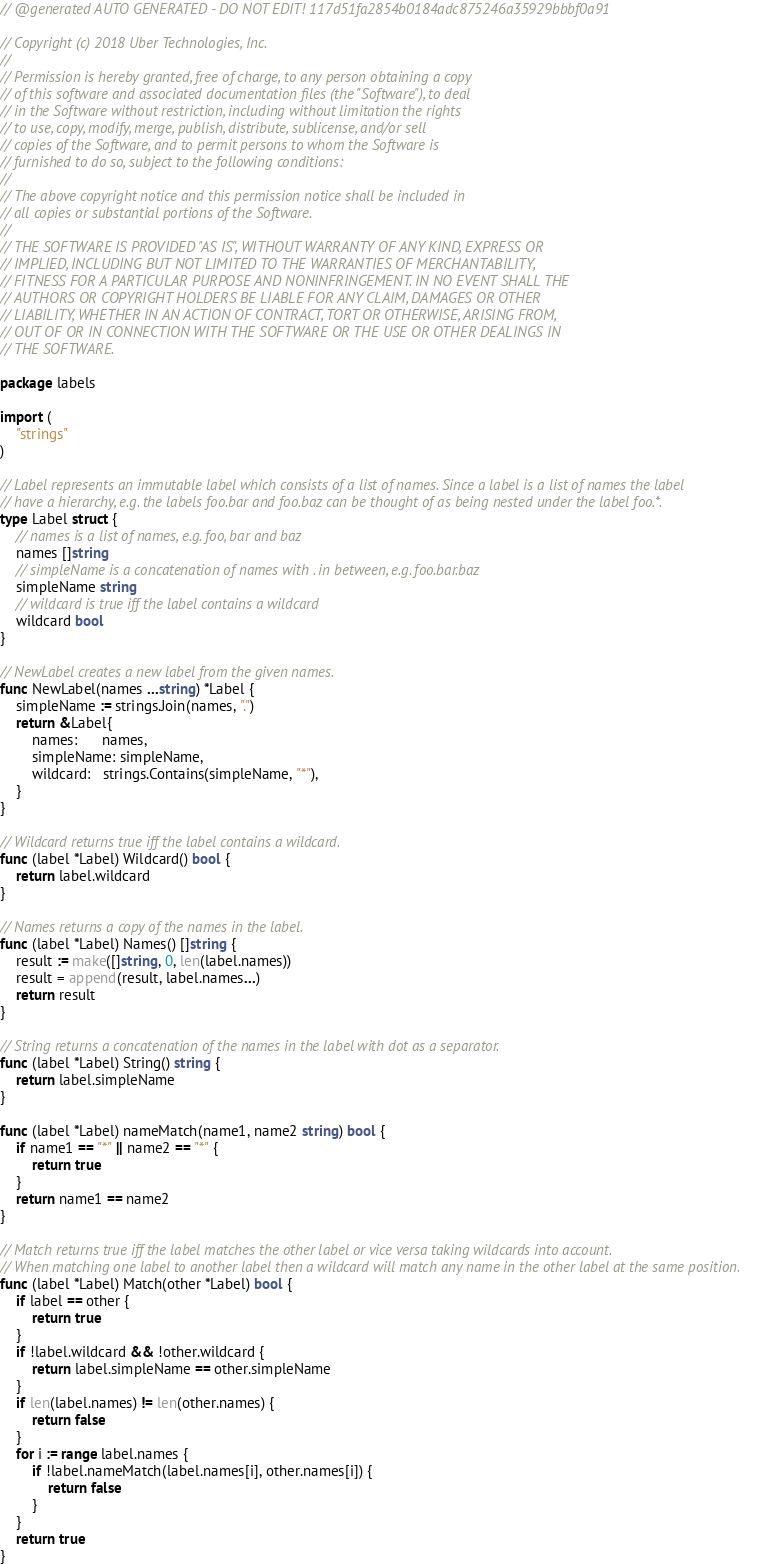Convert code to text. <code><loc_0><loc_0><loc_500><loc_500><_Go_>// @generated AUTO GENERATED - DO NOT EDIT! 117d51fa2854b0184adc875246a35929bbbf0a91

// Copyright (c) 2018 Uber Technologies, Inc.
//
// Permission is hereby granted, free of charge, to any person obtaining a copy
// of this software and associated documentation files (the "Software"), to deal
// in the Software without restriction, including without limitation the rights
// to use, copy, modify, merge, publish, distribute, sublicense, and/or sell
// copies of the Software, and to permit persons to whom the Software is
// furnished to do so, subject to the following conditions:
//
// The above copyright notice and this permission notice shall be included in
// all copies or substantial portions of the Software.
//
// THE SOFTWARE IS PROVIDED "AS IS", WITHOUT WARRANTY OF ANY KIND, EXPRESS OR
// IMPLIED, INCLUDING BUT NOT LIMITED TO THE WARRANTIES OF MERCHANTABILITY,
// FITNESS FOR A PARTICULAR PURPOSE AND NONINFRINGEMENT. IN NO EVENT SHALL THE
// AUTHORS OR COPYRIGHT HOLDERS BE LIABLE FOR ANY CLAIM, DAMAGES OR OTHER
// LIABILITY, WHETHER IN AN ACTION OF CONTRACT, TORT OR OTHERWISE, ARISING FROM,
// OUT OF OR IN CONNECTION WITH THE SOFTWARE OR THE USE OR OTHER DEALINGS IN
// THE SOFTWARE.

package labels

import (
	"strings"
)

// Label represents an immutable label which consists of a list of names. Since a label is a list of names the label
// have a hierarchy, e.g. the labels foo.bar and foo.baz can be thought of as being nested under the label foo.*.
type Label struct {
	// names is a list of names, e.g. foo, bar and baz
	names []string
	// simpleName is a concatenation of names with . in between, e.g. foo.bar.baz
	simpleName string
	// wildcard is true iff the label contains a wildcard
	wildcard bool
}

// NewLabel creates a new label from the given names.
func NewLabel(names ...string) *Label {
	simpleName := strings.Join(names, ".")
	return &Label{
		names:      names,
		simpleName: simpleName,
		wildcard:   strings.Contains(simpleName, "*"),
	}
}

// Wildcard returns true iff the label contains a wildcard.
func (label *Label) Wildcard() bool {
	return label.wildcard
}

// Names returns a copy of the names in the label.
func (label *Label) Names() []string {
	result := make([]string, 0, len(label.names))
	result = append(result, label.names...)
	return result
}

// String returns a concatenation of the names in the label with dot as a separator.
func (label *Label) String() string {
	return label.simpleName
}

func (label *Label) nameMatch(name1, name2 string) bool {
	if name1 == "*" || name2 == "*" {
		return true
	}
	return name1 == name2
}

// Match returns true iff the label matches the other label or vice versa taking wildcards into account.
// When matching one label to another label then a wildcard will match any name in the other label at the same position.
func (label *Label) Match(other *Label) bool {
	if label == other {
		return true
	}
	if !label.wildcard && !other.wildcard {
		return label.simpleName == other.simpleName
	}
	if len(label.names) != len(other.names) {
		return false
	}
	for i := range label.names {
		if !label.nameMatch(label.names[i], other.names[i]) {
			return false
		}
	}
	return true
}
</code> 